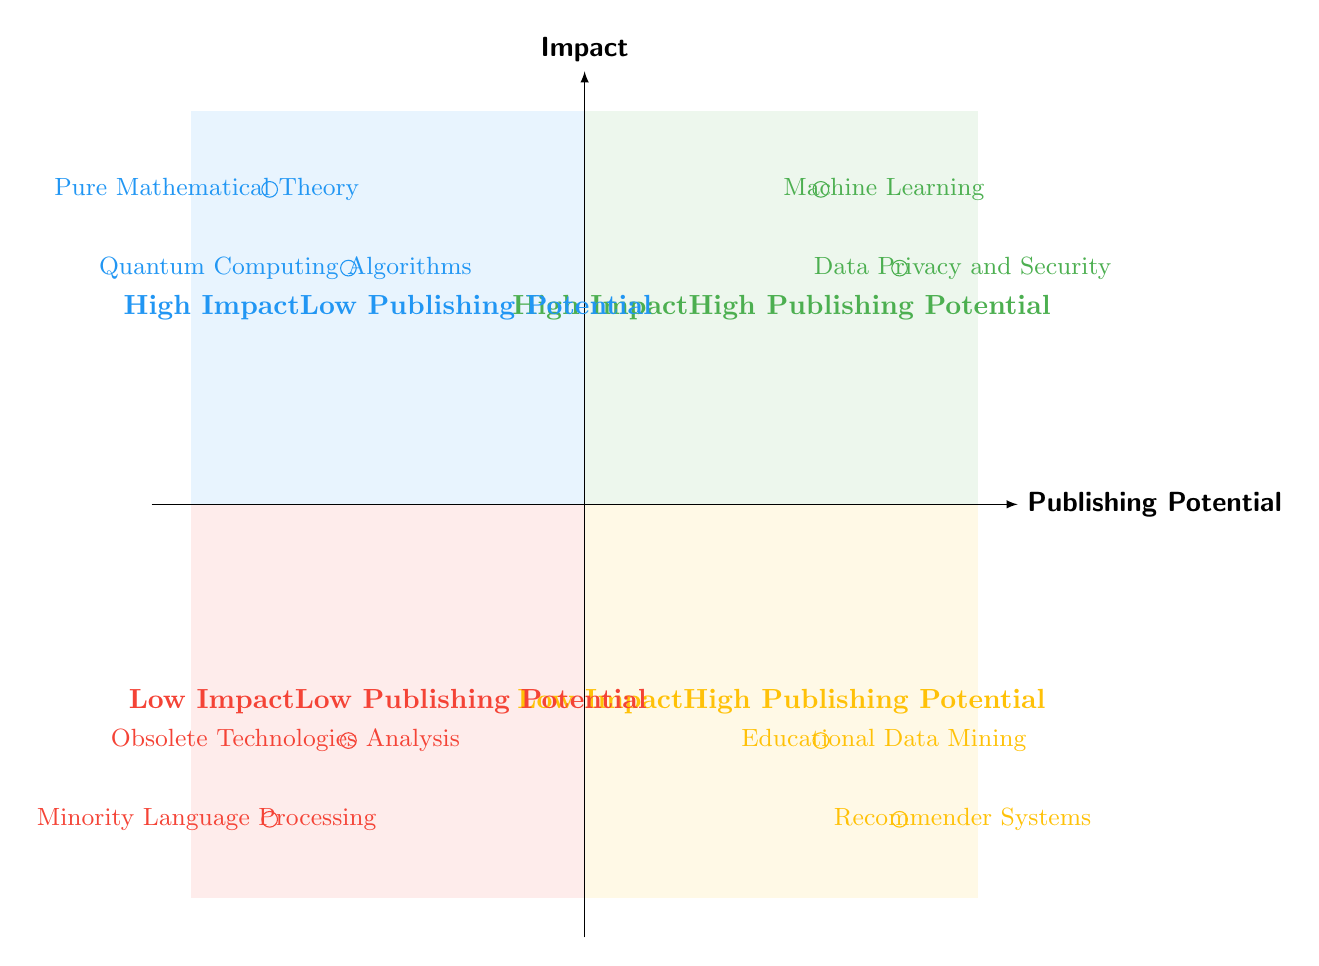What research topic is in the high impact high publishing potential quadrant? The diagram shows two topics in the high impact high publishing potential quadrant: "Machine Learning" and "Data Privacy and Security."
Answer: Machine Learning How many topics are in the low impact low publishing potential quadrant? There are two topics displayed in the low impact low publishing potential quadrant: "Minority Language Processing" and "Obsolete Technologies Analysis."
Answer: 2 Which research topic has low impact but high publishing potential? The topics in the low impact high publishing potential quadrant include "Educational Data Mining" and "Recommender Systems."
Answer: Educational Data Mining What are the example papers of the topic "Machine Learning"? Referring to the high impact high publishing potential quadrant, the example papers for "Machine Learning" are "Deep Neural Networks for Image Classification" and "Support Vector Machines for Pattern Recognition."
Answer: Deep Neural Networks for Image Classification, Support Vector Machines for Pattern Recognition Which quadrant contains both "Pure Mathematical Theory" and "Quantum Computing Algorithms"? The quadrant with "Pure Mathematical Theory" and "Quantum Computing Algorithms" is the high impact low publishing potential quadrant, indicating that both topics have significant research value but less potential for publication.
Answer: High Impact Low Publishing Potential Which has a higher publishing potential: "Recommender Systems" or "Educational Data Mining"? "Recommender Systems" is located in the low impact high publishing potential quadrant, while "Educational Data Mining" is also in that same quadrant making them equal in publishing potential.
Answer: Equal How many quadrants are present in the diagram? The diagram displays a total of four quadrants, each representing a combination of impact and publishing potential.
Answer: 4 Which quadrant would you find "Data Privacy and Security"? "Data Privacy and Security" is located in the high impact high publishing potential quadrant, representing influential research with significant publishing opportunities.
Answer: High Impact High Publishing Potential 